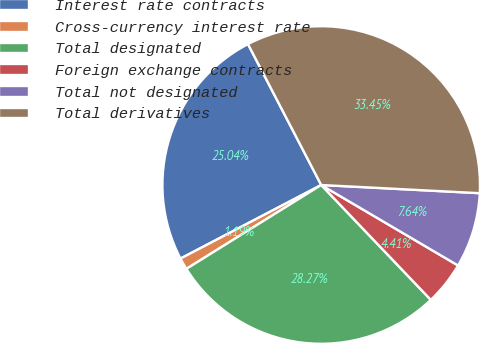Convert chart. <chart><loc_0><loc_0><loc_500><loc_500><pie_chart><fcel>Interest rate contracts<fcel>Cross-currency interest rate<fcel>Total designated<fcel>Foreign exchange contracts<fcel>Total not designated<fcel>Total derivatives<nl><fcel>25.04%<fcel>1.19%<fcel>28.27%<fcel>4.41%<fcel>7.64%<fcel>33.45%<nl></chart> 